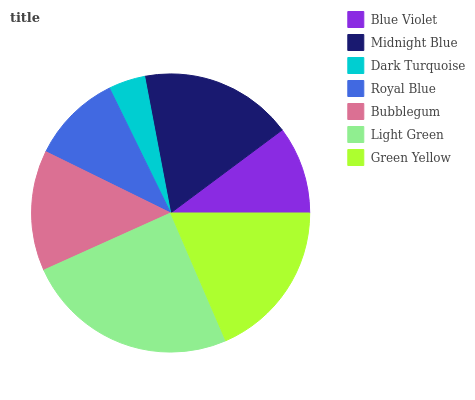Is Dark Turquoise the minimum?
Answer yes or no. Yes. Is Light Green the maximum?
Answer yes or no. Yes. Is Midnight Blue the minimum?
Answer yes or no. No. Is Midnight Blue the maximum?
Answer yes or no. No. Is Midnight Blue greater than Blue Violet?
Answer yes or no. Yes. Is Blue Violet less than Midnight Blue?
Answer yes or no. Yes. Is Blue Violet greater than Midnight Blue?
Answer yes or no. No. Is Midnight Blue less than Blue Violet?
Answer yes or no. No. Is Bubblegum the high median?
Answer yes or no. Yes. Is Bubblegum the low median?
Answer yes or no. Yes. Is Dark Turquoise the high median?
Answer yes or no. No. Is Midnight Blue the low median?
Answer yes or no. No. 